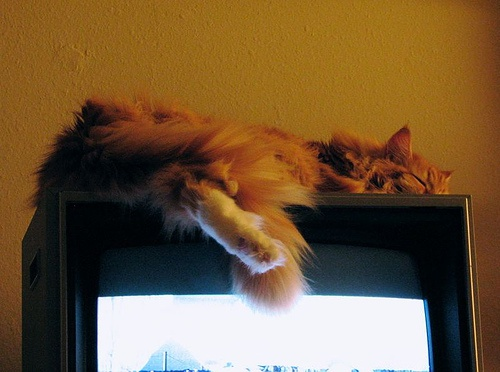Describe the objects in this image and their specific colors. I can see tv in maroon, black, white, darkblue, and blue tones and cat in maroon, black, and brown tones in this image. 